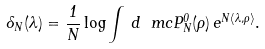<formula> <loc_0><loc_0><loc_500><loc_500>\Lambda _ { N } ( \lambda ) = \frac { 1 } { N } \log \int \, d \ m c P _ { N } ^ { 0 } ( \rho ) \, e ^ { N \langle \lambda , \rho \rangle } .</formula> 